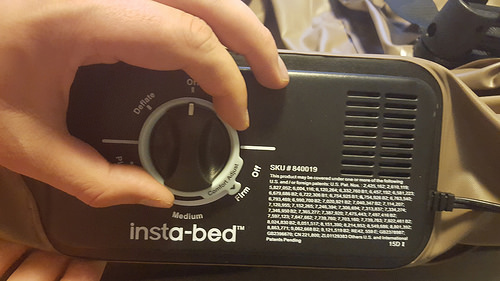<image>
Can you confirm if the knob is under the finger? Yes. The knob is positioned underneath the finger, with the finger above it in the vertical space. 